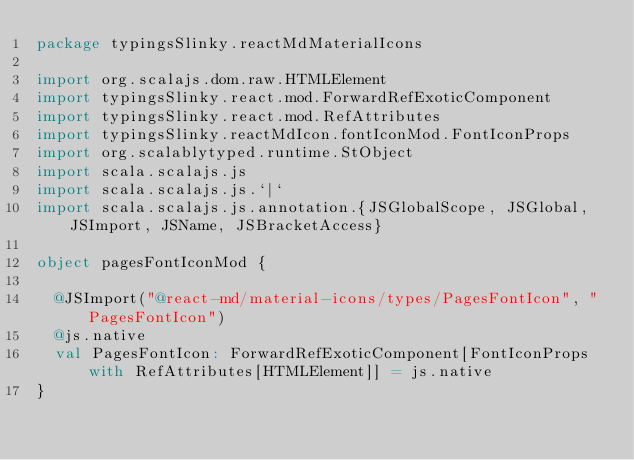Convert code to text. <code><loc_0><loc_0><loc_500><loc_500><_Scala_>package typingsSlinky.reactMdMaterialIcons

import org.scalajs.dom.raw.HTMLElement
import typingsSlinky.react.mod.ForwardRefExoticComponent
import typingsSlinky.react.mod.RefAttributes
import typingsSlinky.reactMdIcon.fontIconMod.FontIconProps
import org.scalablytyped.runtime.StObject
import scala.scalajs.js
import scala.scalajs.js.`|`
import scala.scalajs.js.annotation.{JSGlobalScope, JSGlobal, JSImport, JSName, JSBracketAccess}

object pagesFontIconMod {
  
  @JSImport("@react-md/material-icons/types/PagesFontIcon", "PagesFontIcon")
  @js.native
  val PagesFontIcon: ForwardRefExoticComponent[FontIconProps with RefAttributes[HTMLElement]] = js.native
}
</code> 